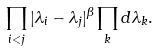<formula> <loc_0><loc_0><loc_500><loc_500>\prod _ { i < j } | \lambda _ { i } - \lambda _ { j } | ^ { \beta } \prod _ { k } d \lambda _ { k } .</formula> 